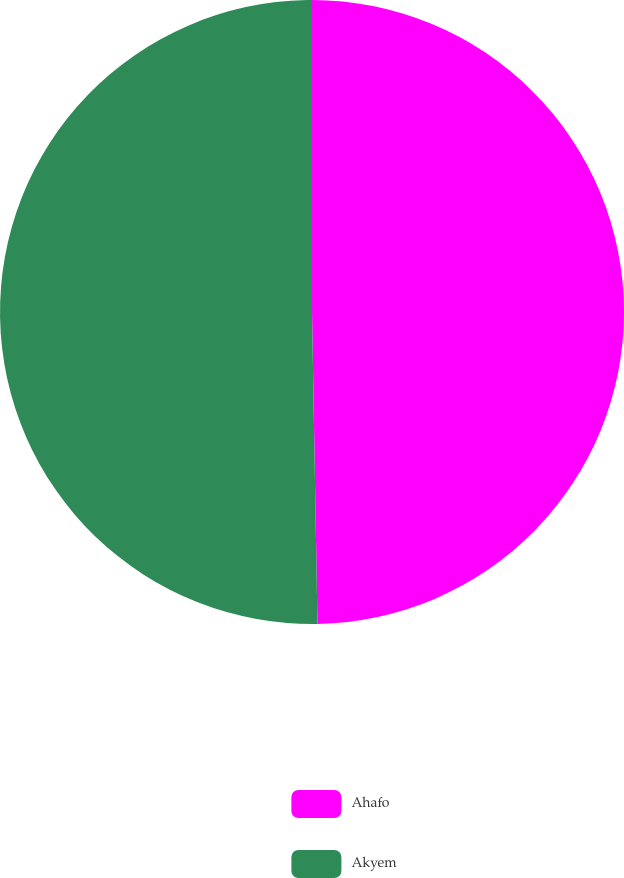Convert chart. <chart><loc_0><loc_0><loc_500><loc_500><pie_chart><fcel>Ahafo<fcel>Akyem<nl><fcel>49.72%<fcel>50.28%<nl></chart> 